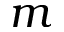<formula> <loc_0><loc_0><loc_500><loc_500>m</formula> 